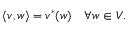Convert formula to latex. <formula><loc_0><loc_0><loc_500><loc_500>\langle v , w \rangle = v ^ { * } ( w ) \quad \forall w \in V .</formula> 